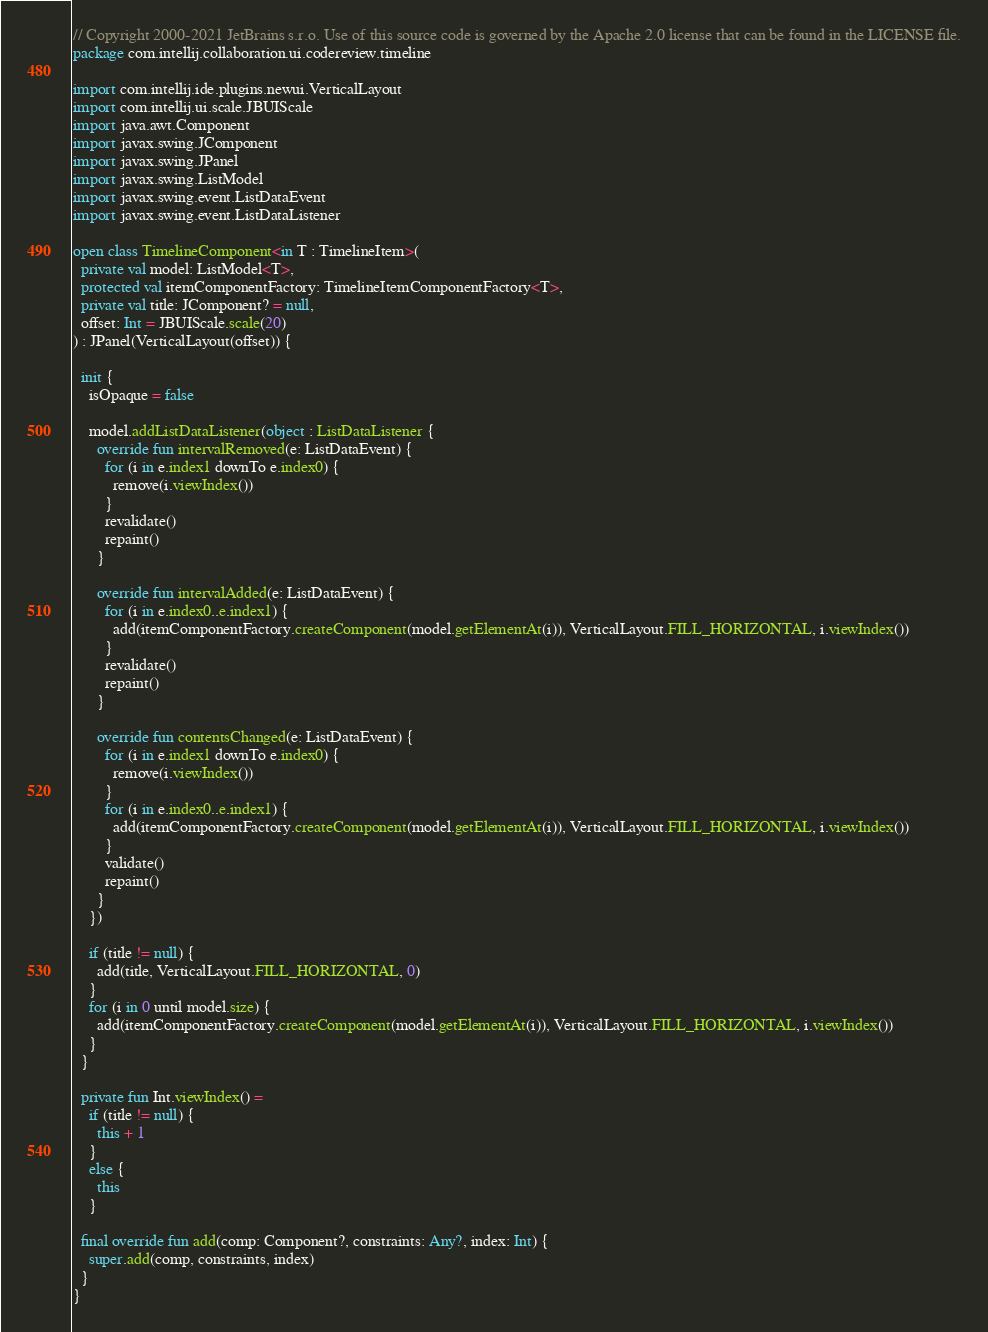<code> <loc_0><loc_0><loc_500><loc_500><_Kotlin_>// Copyright 2000-2021 JetBrains s.r.o. Use of this source code is governed by the Apache 2.0 license that can be found in the LICENSE file.
package com.intellij.collaboration.ui.codereview.timeline

import com.intellij.ide.plugins.newui.VerticalLayout
import com.intellij.ui.scale.JBUIScale
import java.awt.Component
import javax.swing.JComponent
import javax.swing.JPanel
import javax.swing.ListModel
import javax.swing.event.ListDataEvent
import javax.swing.event.ListDataListener

open class TimelineComponent<in T : TimelineItem>(
  private val model: ListModel<T>,
  protected val itemComponentFactory: TimelineItemComponentFactory<T>,
  private val title: JComponent? = null,
  offset: Int = JBUIScale.scale(20)
) : JPanel(VerticalLayout(offset)) {

  init {
    isOpaque = false

    model.addListDataListener(object : ListDataListener {
      override fun intervalRemoved(e: ListDataEvent) {
        for (i in e.index1 downTo e.index0) {
          remove(i.viewIndex())
        }
        revalidate()
        repaint()
      }

      override fun intervalAdded(e: ListDataEvent) {
        for (i in e.index0..e.index1) {
          add(itemComponentFactory.createComponent(model.getElementAt(i)), VerticalLayout.FILL_HORIZONTAL, i.viewIndex())
        }
        revalidate()
        repaint()
      }

      override fun contentsChanged(e: ListDataEvent) {
        for (i in e.index1 downTo e.index0) {
          remove(i.viewIndex())
        }
        for (i in e.index0..e.index1) {
          add(itemComponentFactory.createComponent(model.getElementAt(i)), VerticalLayout.FILL_HORIZONTAL, i.viewIndex())
        }
        validate()
        repaint()
      }
    })

    if (title != null) {
      add(title, VerticalLayout.FILL_HORIZONTAL, 0)
    }
    for (i in 0 until model.size) {
      add(itemComponentFactory.createComponent(model.getElementAt(i)), VerticalLayout.FILL_HORIZONTAL, i.viewIndex())
    }
  }

  private fun Int.viewIndex() =
    if (title != null) {
      this + 1
    }
    else {
      this
    }

  final override fun add(comp: Component?, constraints: Any?, index: Int) {
    super.add(comp, constraints, index)
  }
}</code> 